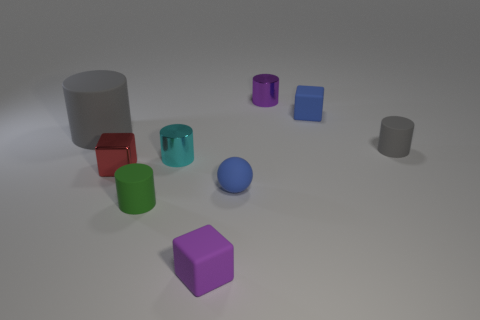Subtract all cyan shiny cylinders. How many cylinders are left? 4 Subtract all cyan cylinders. How many cylinders are left? 4 Subtract all brown cylinders. Subtract all gray balls. How many cylinders are left? 5 Subtract all cubes. How many objects are left? 6 Add 7 balls. How many balls exist? 8 Subtract 0 red cylinders. How many objects are left? 9 Subtract all red metallic blocks. Subtract all cylinders. How many objects are left? 3 Add 6 small blue objects. How many small blue objects are left? 8 